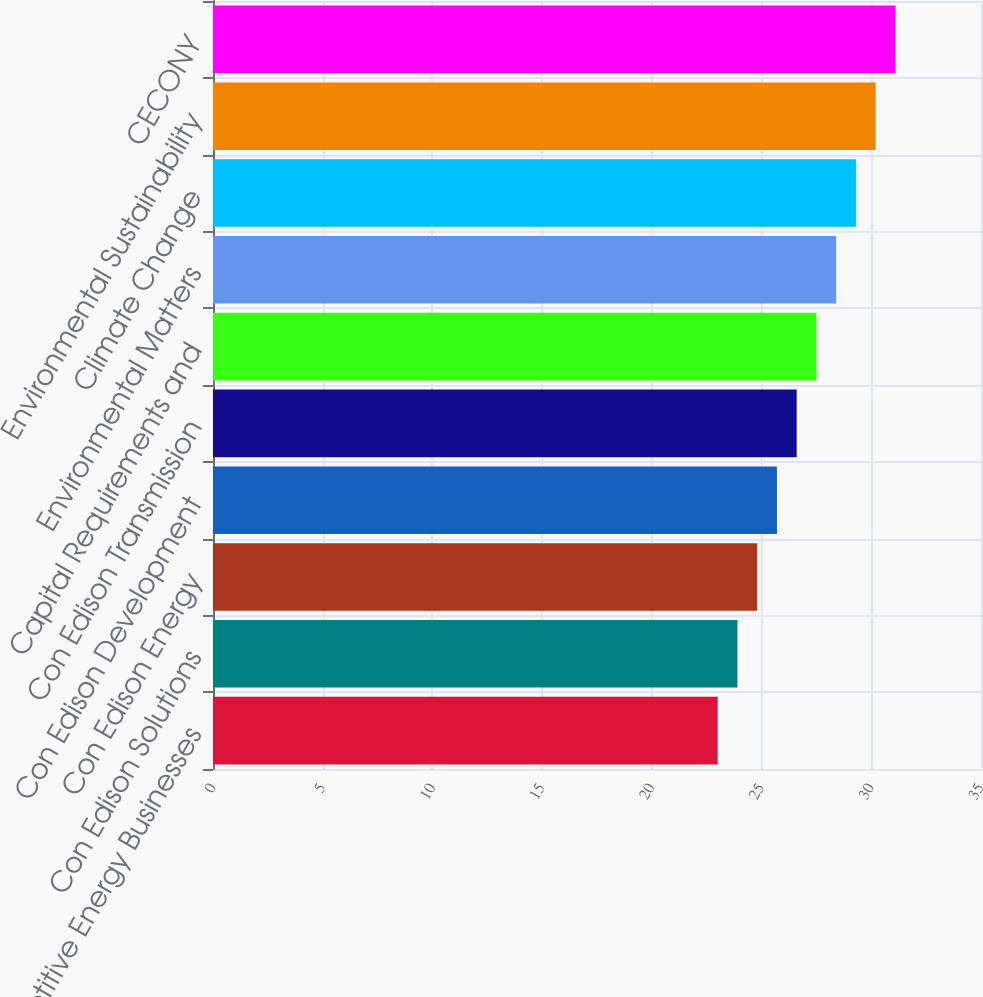Convert chart to OTSL. <chart><loc_0><loc_0><loc_500><loc_500><bar_chart><fcel>Competitive Energy Businesses<fcel>Con Edison Solutions<fcel>Con Edison Energy<fcel>Con Edison Development<fcel>Con Edison Transmission<fcel>Capital Requirements and<fcel>Environmental Matters<fcel>Climate Change<fcel>Environmental Sustainability<fcel>CECONY<nl><fcel>23<fcel>23.9<fcel>24.8<fcel>25.7<fcel>26.6<fcel>27.5<fcel>28.4<fcel>29.3<fcel>30.2<fcel>31.1<nl></chart> 